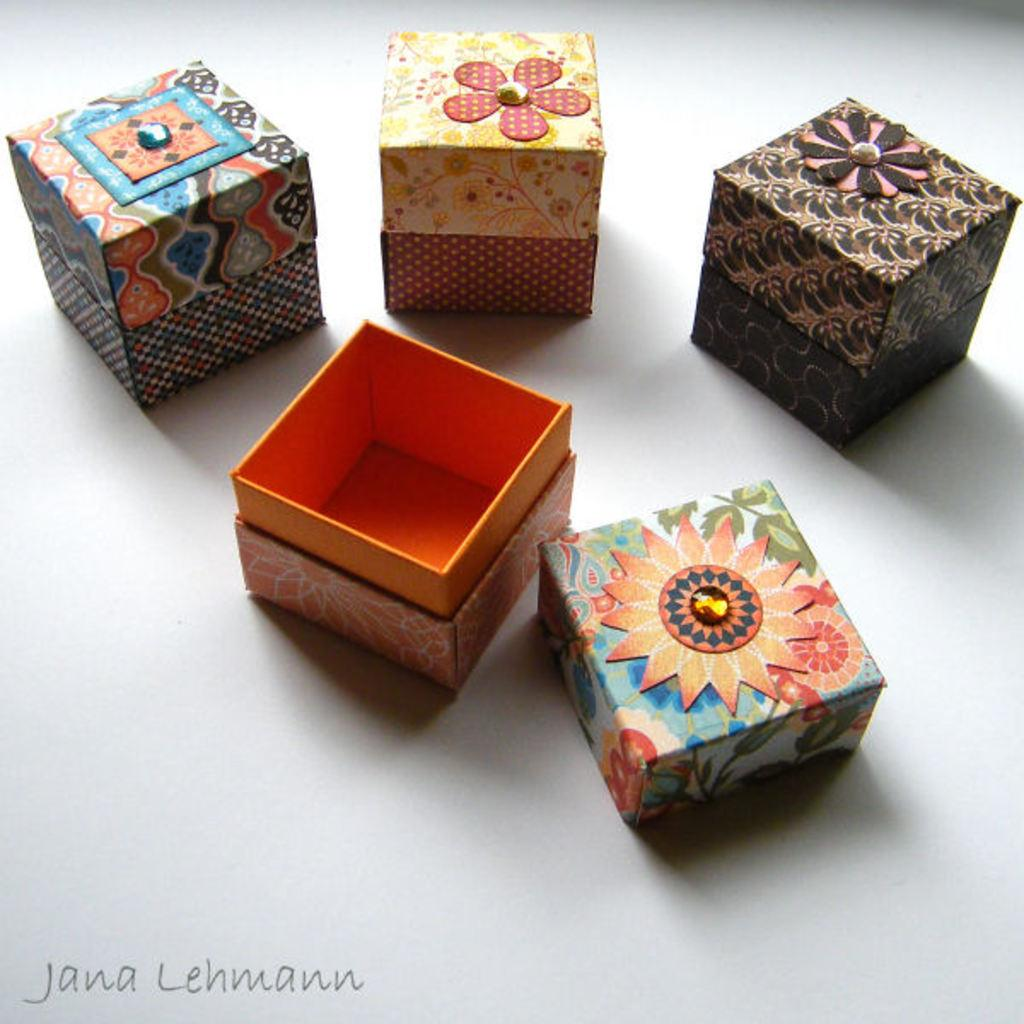<image>
Present a compact description of the photo's key features. Jana Lehmann is the photographer for those boxes. 